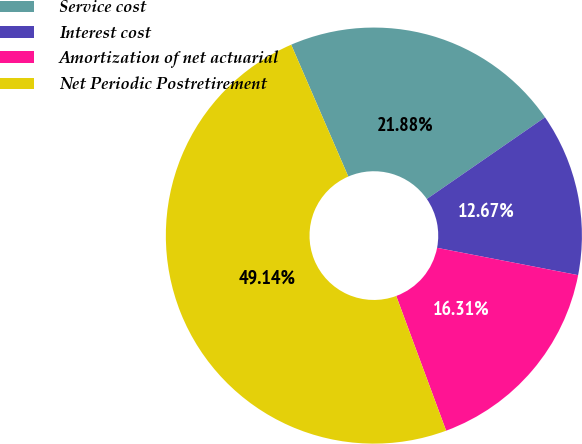<chart> <loc_0><loc_0><loc_500><loc_500><pie_chart><fcel>Service cost<fcel>Interest cost<fcel>Amortization of net actuarial<fcel>Net Periodic Postretirement<nl><fcel>21.88%<fcel>12.67%<fcel>16.31%<fcel>49.14%<nl></chart> 